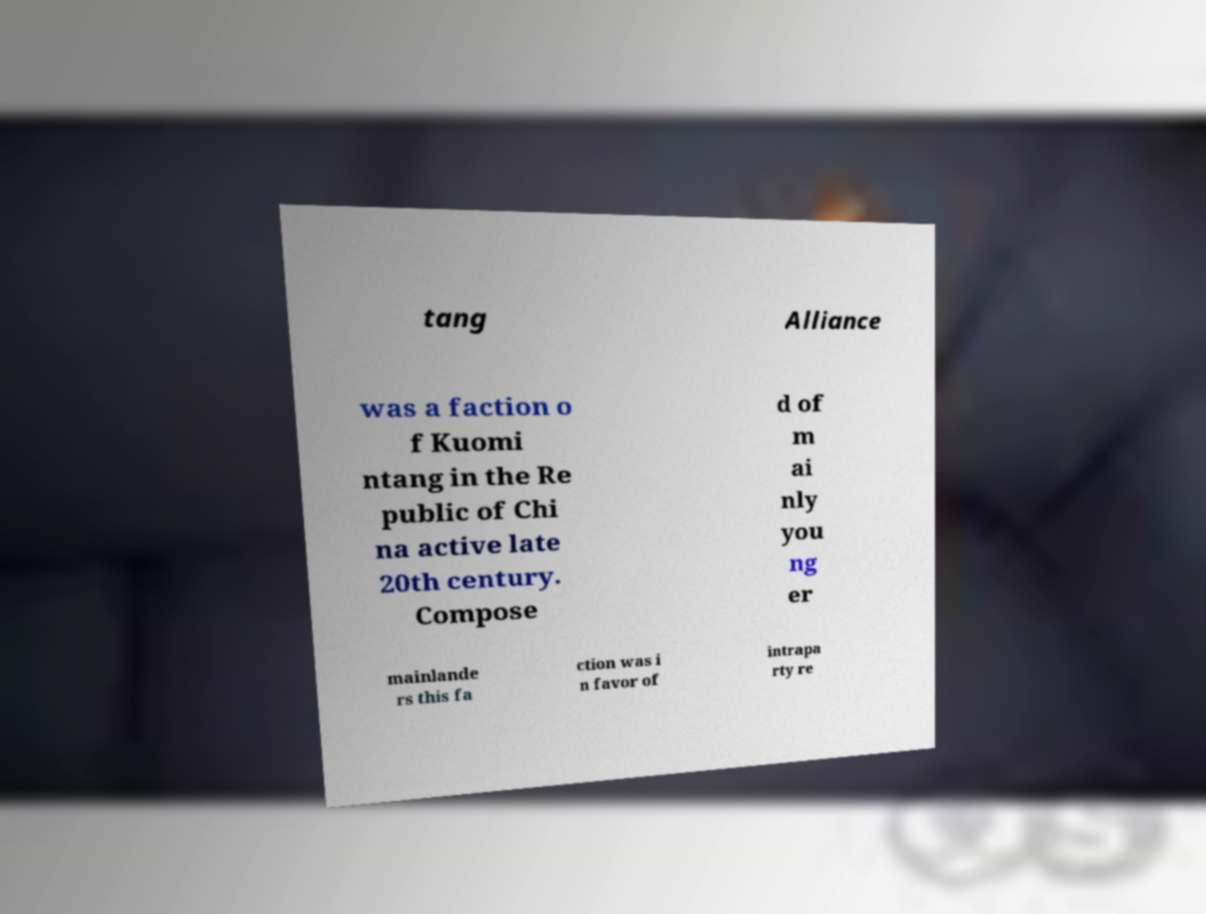Can you accurately transcribe the text from the provided image for me? tang Alliance was a faction o f Kuomi ntang in the Re public of Chi na active late 20th century. Compose d of m ai nly you ng er mainlande rs this fa ction was i n favor of intrapa rty re 